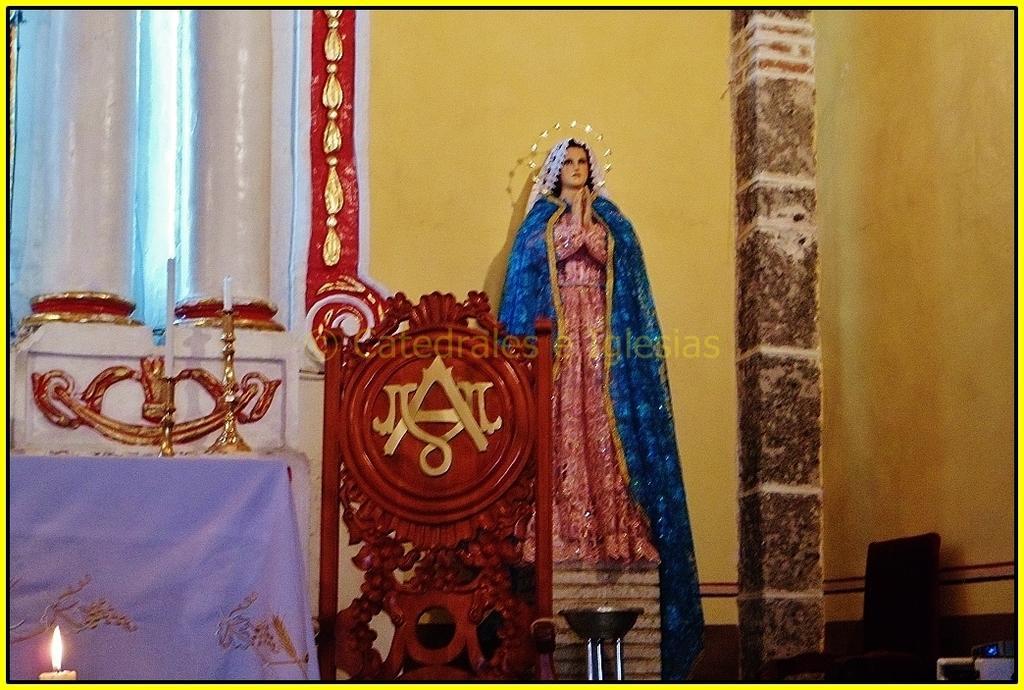Can you describe this image briefly? In this image I can see few candles on the left side and in the centre I can see a logo on a brown colour thing. I can also see a sculpture in the background and near it I can see an object. I can also see a watermark in the centre of this image and on the right side I can see a chair. 